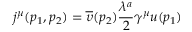<formula> <loc_0><loc_0><loc_500><loc_500>j ^ { \mu } ( p _ { 1 } , p _ { 2 } ) = \overline { \upsilon } ( p _ { 2 } ) \frac { \lambda ^ { a } } 2 \gamma ^ { \mu } u ( p _ { 1 } )</formula> 